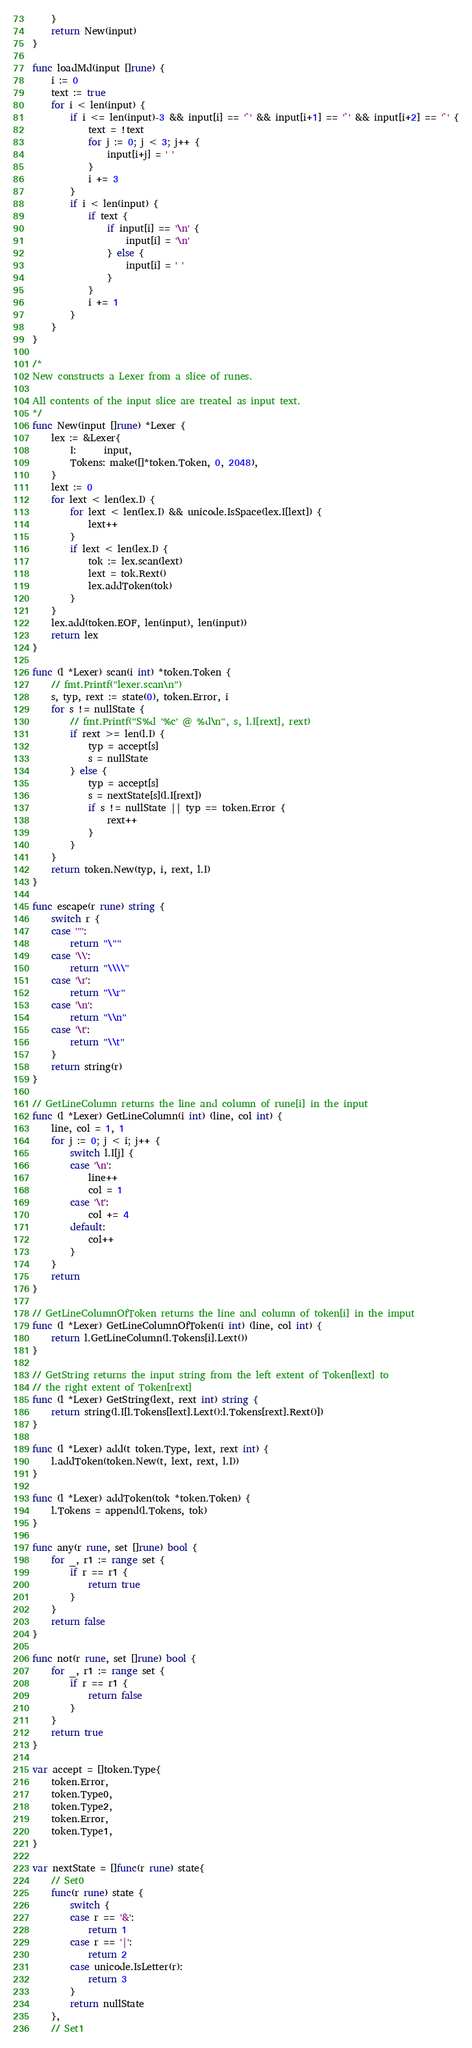<code> <loc_0><loc_0><loc_500><loc_500><_Go_>	}
	return New(input)
}

func loadMd(input []rune) {
	i := 0
	text := true
	for i < len(input) {
		if i <= len(input)-3 && input[i] == '`' && input[i+1] == '`' && input[i+2] == '`' {
			text = !text
			for j := 0; j < 3; j++ {
				input[i+j] = ' '
			}
			i += 3
		}
		if i < len(input) {
			if text {
				if input[i] == '\n' {
					input[i] = '\n'
				} else {
					input[i] = ' '
				}
			}
			i += 1
		}
	}
}

/*
New constructs a Lexer from a slice of runes. 

All contents of the input slice are treated as input text.
*/
func New(input []rune) *Lexer {
	lex := &Lexer{
		I:      input,
		Tokens: make([]*token.Token, 0, 2048),
	}
	lext := 0
	for lext < len(lex.I) {
		for lext < len(lex.I) && unicode.IsSpace(lex.I[lext]) {
			lext++
		}
		if lext < len(lex.I) {
			tok := lex.scan(lext)
			lext = tok.Rext()
			lex.addToken(tok)
		}
	}
	lex.add(token.EOF, len(input), len(input))
	return lex
}

func (l *Lexer) scan(i int) *token.Token {
	// fmt.Printf("lexer.scan\n")
	s, typ, rext := state(0), token.Error, i
	for s != nullState {
		// fmt.Printf("S%d '%c' @ %d\n", s, l.I[rext], rext)
		if rext >= len(l.I) {
			typ = accept[s]
			s = nullState
		} else {
			typ = accept[s]
			s = nextState[s](l.I[rext])
			if s != nullState || typ == token.Error {
				rext++
			}
		}
	}
	return token.New(typ, i, rext, l.I)
}

func escape(r rune) string {
	switch r {
	case '"':
		return "\""
	case '\\':
		return "\\\\"
	case '\r':
		return "\\r"
	case '\n':
		return "\\n"
	case '\t':
		return "\\t"
	}
	return string(r)
}

// GetLineColumn returns the line and column of rune[i] in the input
func (l *Lexer) GetLineColumn(i int) (line, col int) {
	line, col = 1, 1
	for j := 0; j < i; j++ {
		switch l.I[j] {
		case '\n':
			line++
			col = 1
		case '\t':
			col += 4
		default:
			col++
		}
	}
	return
}

// GetLineColumnOfToken returns the line and column of token[i] in the imput
func (l *Lexer) GetLineColumnOfToken(i int) (line, col int) {
	return l.GetLineColumn(l.Tokens[i].Lext())
}

// GetString returns the input string from the left extent of Token[lext] to
// the right extent of Token[rext]
func (l *Lexer) GetString(lext, rext int) string {
	return string(l.I[l.Tokens[lext].Lext():l.Tokens[rext].Rext()])
}

func (l *Lexer) add(t token.Type, lext, rext int) {
	l.addToken(token.New(t, lext, rext, l.I))
}

func (l *Lexer) addToken(tok *token.Token) {
	l.Tokens = append(l.Tokens, tok)
}

func any(r rune, set []rune) bool {
	for _, r1 := range set {
		if r == r1 {
			return true
		}
	}
	return false
}

func not(r rune, set []rune) bool {
	for _, r1 := range set {
		if r == r1 {
			return false
		}
	}
	return true
}

var accept = []token.Type{ 
	token.Error, 
	token.Type0, 
	token.Type2, 
	token.Error, 
	token.Type1, 
}

var nextState = []func(r rune) state{ 
	// Set0
	func(r rune) state {
		switch { 
		case r == '&':
			return 1 
		case r == '|':
			return 2 
		case unicode.IsLetter(r):
			return 3 
		}
		return nullState
	}, 
	// Set1</code> 